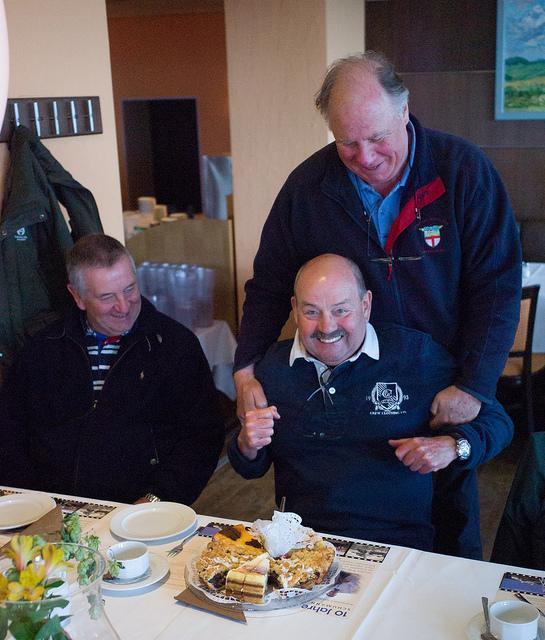How many men are there?
Give a very brief answer. 3. How many people are there?
Give a very brief answer. 3. How many dining tables are there?
Give a very brief answer. 1. How many of the train cars are yellow and red?
Give a very brief answer. 0. 